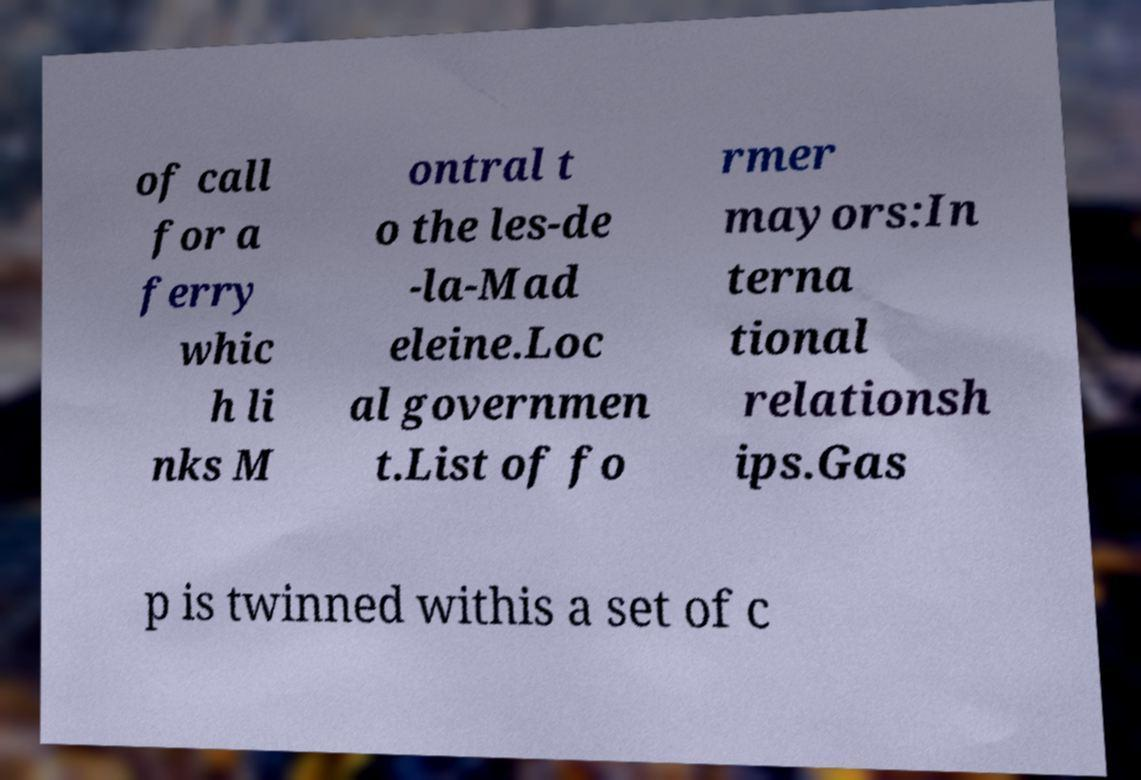Can you read and provide the text displayed in the image?This photo seems to have some interesting text. Can you extract and type it out for me? of call for a ferry whic h li nks M ontral t o the les-de -la-Mad eleine.Loc al governmen t.List of fo rmer mayors:In terna tional relationsh ips.Gas p is twinned withis a set of c 